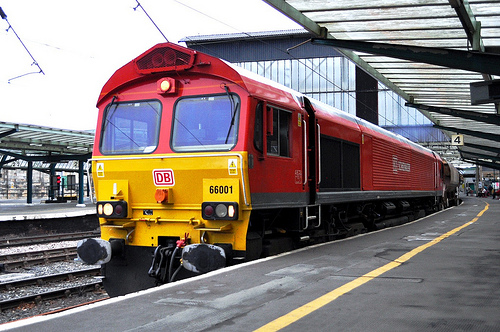<image>
Is the train behind the platform? Yes. From this viewpoint, the train is positioned behind the platform, with the platform partially or fully occluding the train. Where is the train in relation to the sky? Is it in the sky? No. The train is not contained within the sky. These objects have a different spatial relationship. Is the train next to the tracks? Yes. The train is positioned adjacent to the tracks, located nearby in the same general area. 